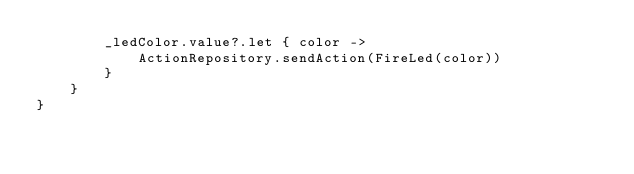<code> <loc_0><loc_0><loc_500><loc_500><_Kotlin_>        _ledColor.value?.let { color ->
            ActionRepository.sendAction(FireLed(color))
        }
    }
}
</code> 